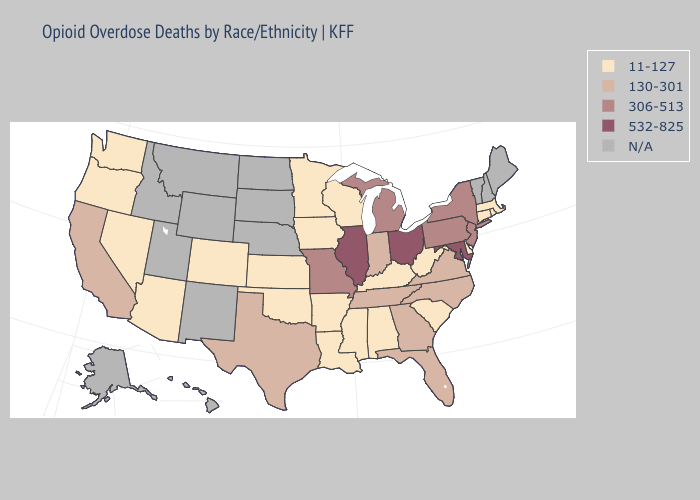Is the legend a continuous bar?
Keep it brief. No. Name the states that have a value in the range N/A?
Short answer required. Alaska, Hawaii, Idaho, Maine, Montana, Nebraska, New Hampshire, New Mexico, North Dakota, South Dakota, Utah, Vermont, Wyoming. What is the highest value in states that border Oklahoma?
Concise answer only. 306-513. Does Illinois have the highest value in the USA?
Short answer required. Yes. Name the states that have a value in the range 306-513?
Be succinct. Michigan, Missouri, New Jersey, New York, Pennsylvania. What is the value of Virginia?
Keep it brief. 130-301. What is the value of Minnesota?
Concise answer only. 11-127. Does North Carolina have the lowest value in the USA?
Give a very brief answer. No. Name the states that have a value in the range 11-127?
Give a very brief answer. Alabama, Arizona, Arkansas, Colorado, Connecticut, Delaware, Iowa, Kansas, Kentucky, Louisiana, Massachusetts, Minnesota, Mississippi, Nevada, Oklahoma, Oregon, Rhode Island, South Carolina, Washington, West Virginia, Wisconsin. What is the lowest value in the USA?
Write a very short answer. 11-127. Does North Carolina have the lowest value in the South?
Concise answer only. No. Among the states that border Wyoming , which have the lowest value?
Write a very short answer. Colorado. Name the states that have a value in the range N/A?
Quick response, please. Alaska, Hawaii, Idaho, Maine, Montana, Nebraska, New Hampshire, New Mexico, North Dakota, South Dakota, Utah, Vermont, Wyoming. Name the states that have a value in the range 11-127?
Quick response, please. Alabama, Arizona, Arkansas, Colorado, Connecticut, Delaware, Iowa, Kansas, Kentucky, Louisiana, Massachusetts, Minnesota, Mississippi, Nevada, Oklahoma, Oregon, Rhode Island, South Carolina, Washington, West Virginia, Wisconsin. 